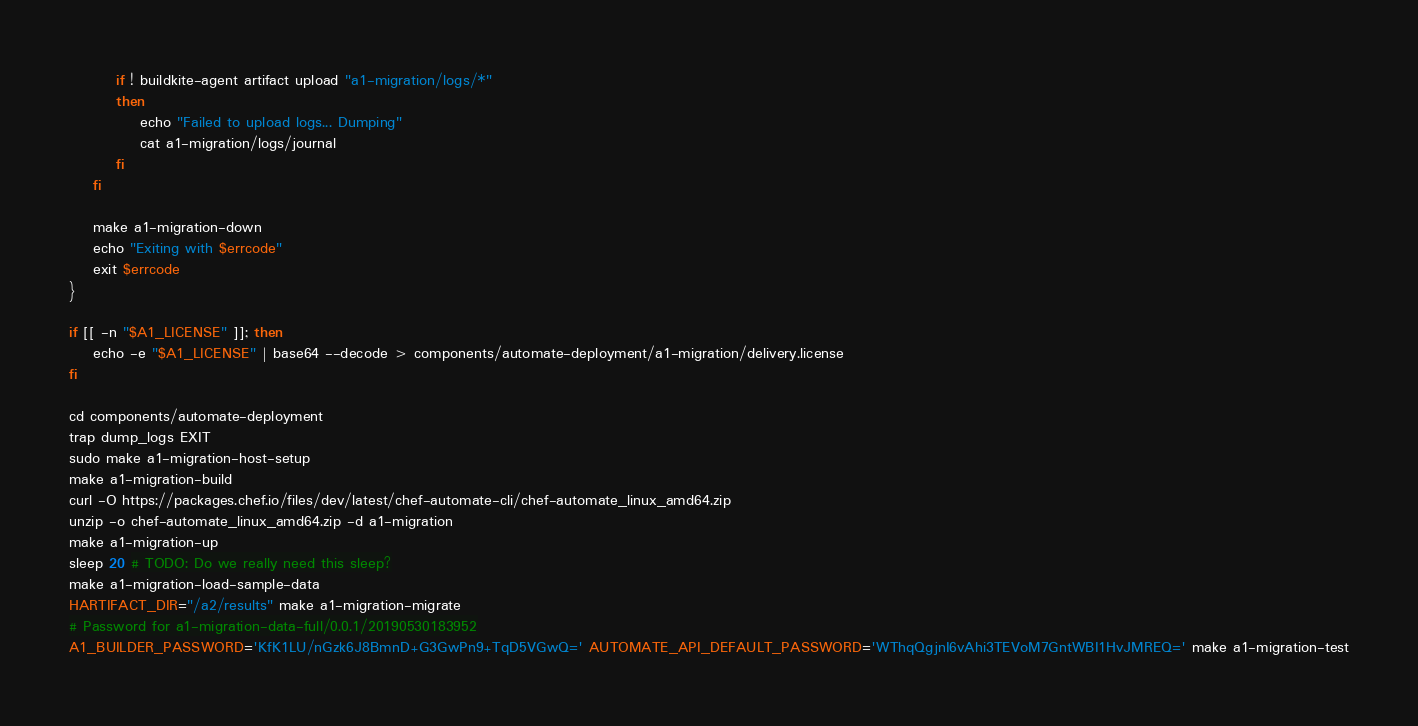Convert code to text. <code><loc_0><loc_0><loc_500><loc_500><_Bash_>
        if ! buildkite-agent artifact upload "a1-migration/logs/*"
        then
            echo "Failed to upload logs... Dumping"
            cat a1-migration/logs/journal
        fi
    fi

    make a1-migration-down
    echo "Exiting with $errcode"
    exit $errcode
}

if [[ -n "$A1_LICENSE" ]]; then
    echo -e "$A1_LICENSE" | base64 --decode > components/automate-deployment/a1-migration/delivery.license
fi

cd components/automate-deployment
trap dump_logs EXIT
sudo make a1-migration-host-setup
make a1-migration-build
curl -O https://packages.chef.io/files/dev/latest/chef-automate-cli/chef-automate_linux_amd64.zip
unzip -o chef-automate_linux_amd64.zip -d a1-migration
make a1-migration-up
sleep 20 # TODO: Do we really need this sleep?
make a1-migration-load-sample-data
HARTIFACT_DIR="/a2/results" make a1-migration-migrate
# Password for a1-migration-data-full/0.0.1/20190530183952
A1_BUILDER_PASSWORD='KfK1LU/nGzk6J8BmnD+G3GwPn9+TqD5VGwQ=' AUTOMATE_API_DEFAULT_PASSWORD='WThqQgjnI6vAhi3TEVoM7GntWBI1HvJMREQ=' make a1-migration-test
</code> 